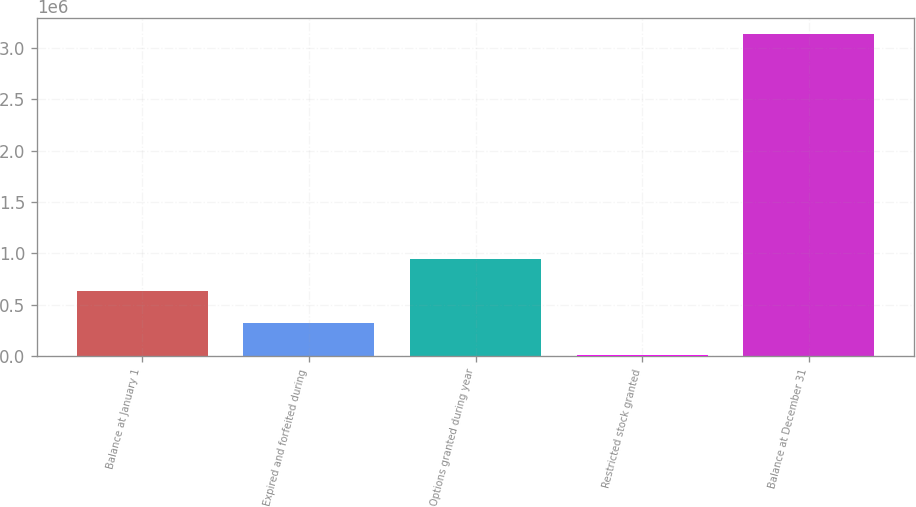Convert chart. <chart><loc_0><loc_0><loc_500><loc_500><bar_chart><fcel>Balance at January 1<fcel>Expired and forfeited during<fcel>Options granted during year<fcel>Restricted stock granted<fcel>Balance at December 31<nl><fcel>635200<fcel>322600<fcel>947800<fcel>10000<fcel>3.136e+06<nl></chart> 